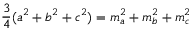Convert formula to latex. <formula><loc_0><loc_0><loc_500><loc_500>{ \frac { 3 } { 4 } } ( a ^ { 2 } + b ^ { 2 } + c ^ { 2 } ) = m _ { a } ^ { 2 } + m _ { b } ^ { 2 } + m _ { c } ^ { 2 }</formula> 